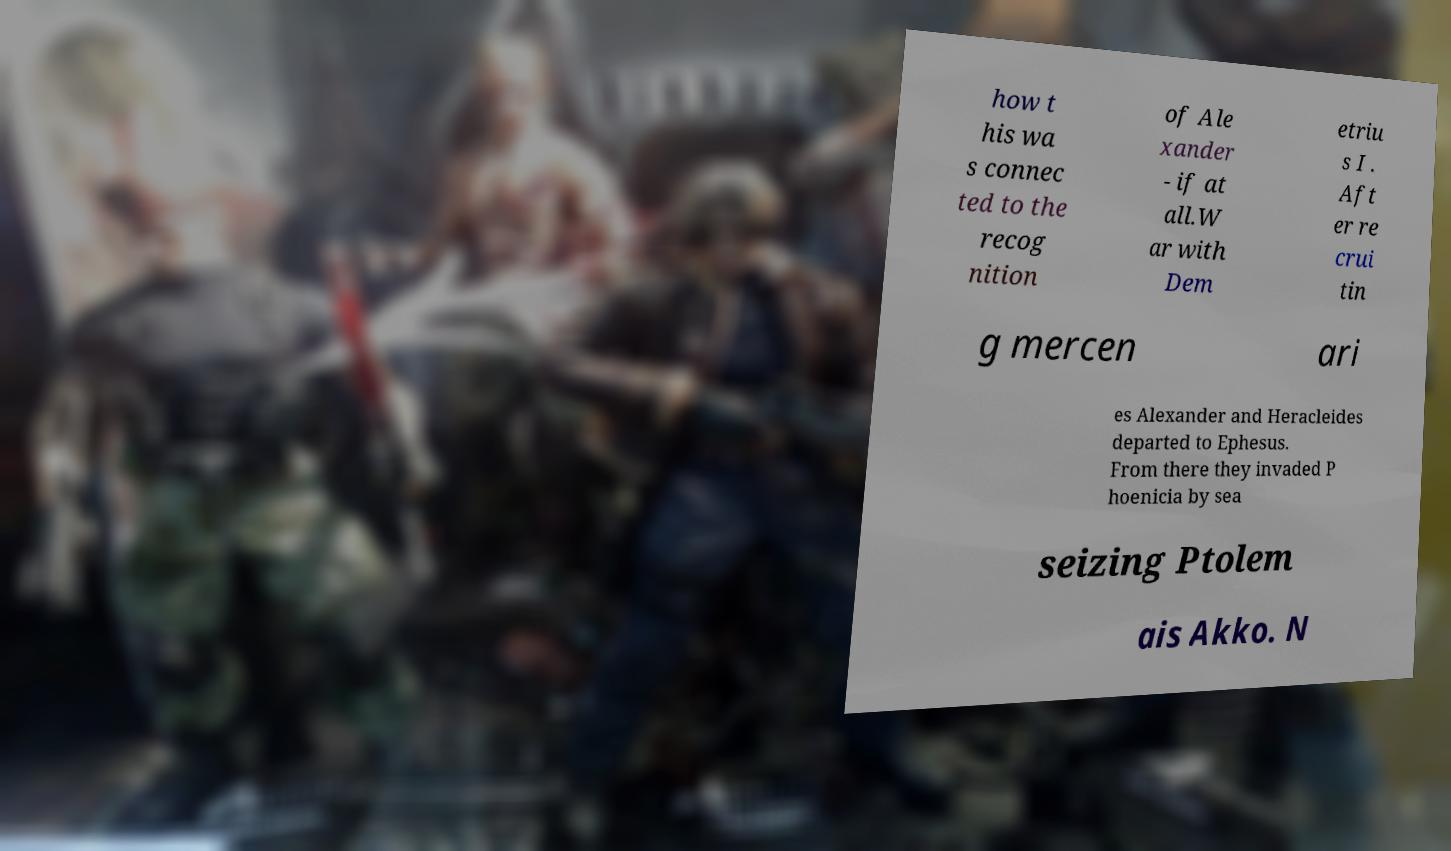Could you extract and type out the text from this image? how t his wa s connec ted to the recog nition of Ale xander - if at all.W ar with Dem etriu s I . Aft er re crui tin g mercen ari es Alexander and Heracleides departed to Ephesus. From there they invaded P hoenicia by sea seizing Ptolem ais Akko. N 